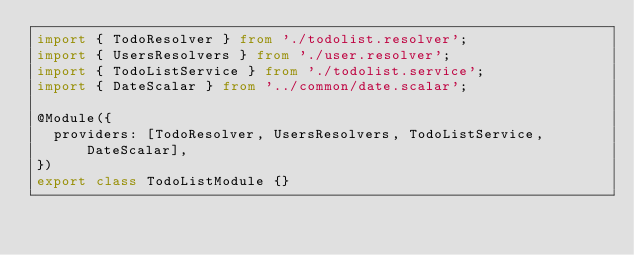<code> <loc_0><loc_0><loc_500><loc_500><_TypeScript_>import { TodoResolver } from './todolist.resolver';
import { UsersResolvers } from './user.resolver';
import { TodoListService } from './todolist.service';
import { DateScalar } from '../common/date.scalar';

@Module({
  providers: [TodoResolver, UsersResolvers, TodoListService, DateScalar],
})
export class TodoListModule {}
</code> 